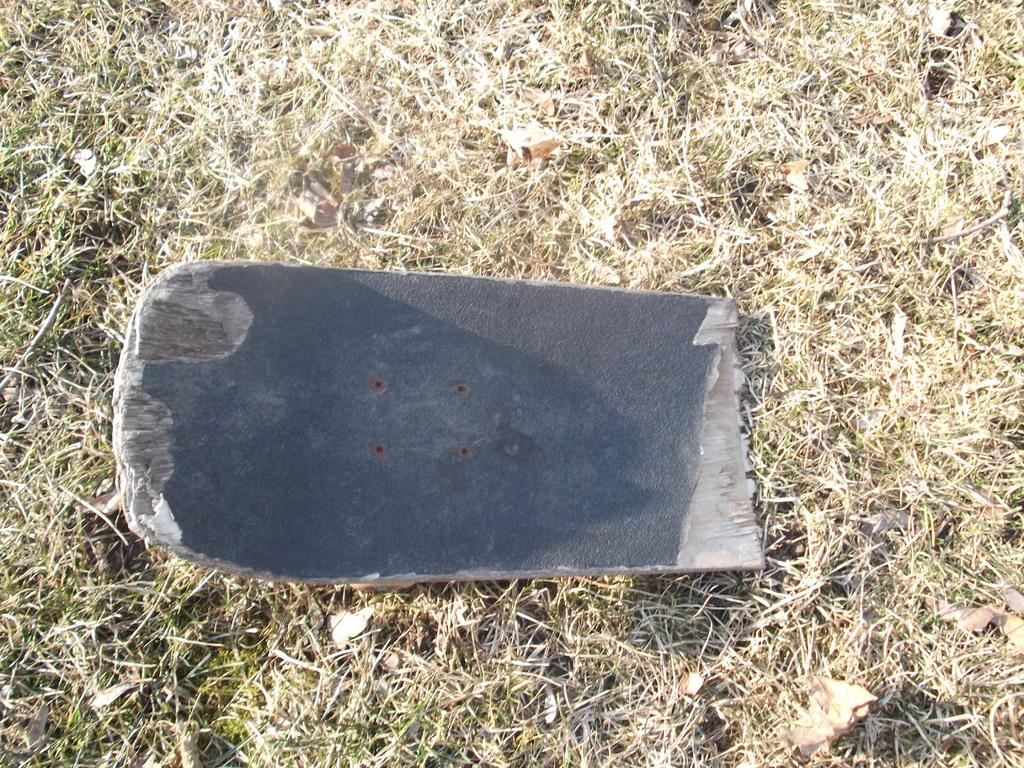What is the main subject in the image? There is an object in the image. What color is the object in the image? The object is in gray color. What can be seen in the background of the image? There is dried grass in the background of the image. Is the object on a stage in the image? There is no mention of a stage in the image, so it cannot be determined if the object is on a stage. What type of silver material is used to make the object? The image does not specify the material of the object, nor does it mention any silver material. 